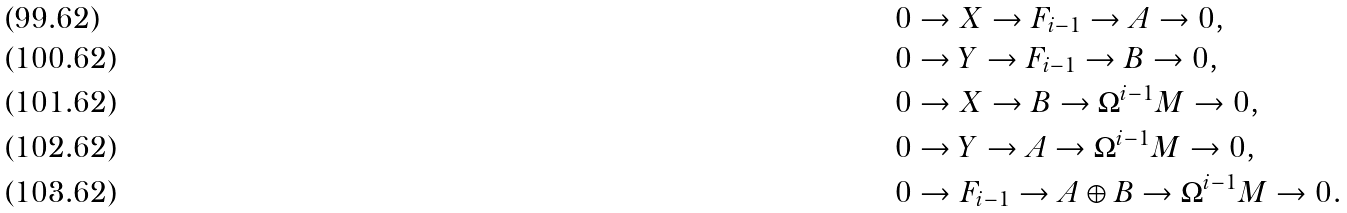Convert formula to latex. <formula><loc_0><loc_0><loc_500><loc_500>& 0 \to X \to F _ { i - 1 } \to A \to 0 , \\ & 0 \to Y \to F _ { i - 1 } \to B \to 0 , \\ & 0 \to X \to B \to \Omega ^ { i - 1 } M \to 0 , \\ & 0 \to Y \to A \to \Omega ^ { i - 1 } M \to 0 , \\ & 0 \to F _ { i - 1 } \to A \oplus B \to \Omega ^ { i - 1 } M \to 0 .</formula> 